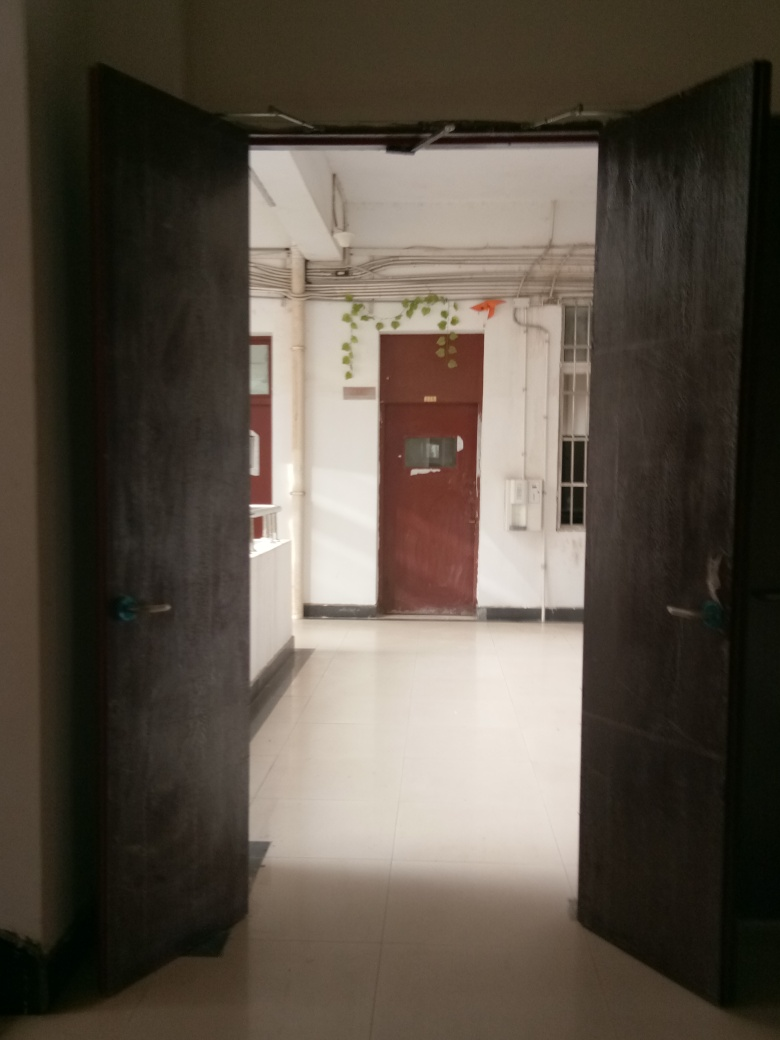What is the main subject of the image?
A. A tree
B. A window
C. A door
Answer with the option's letter from the given choices directly.
 C. 